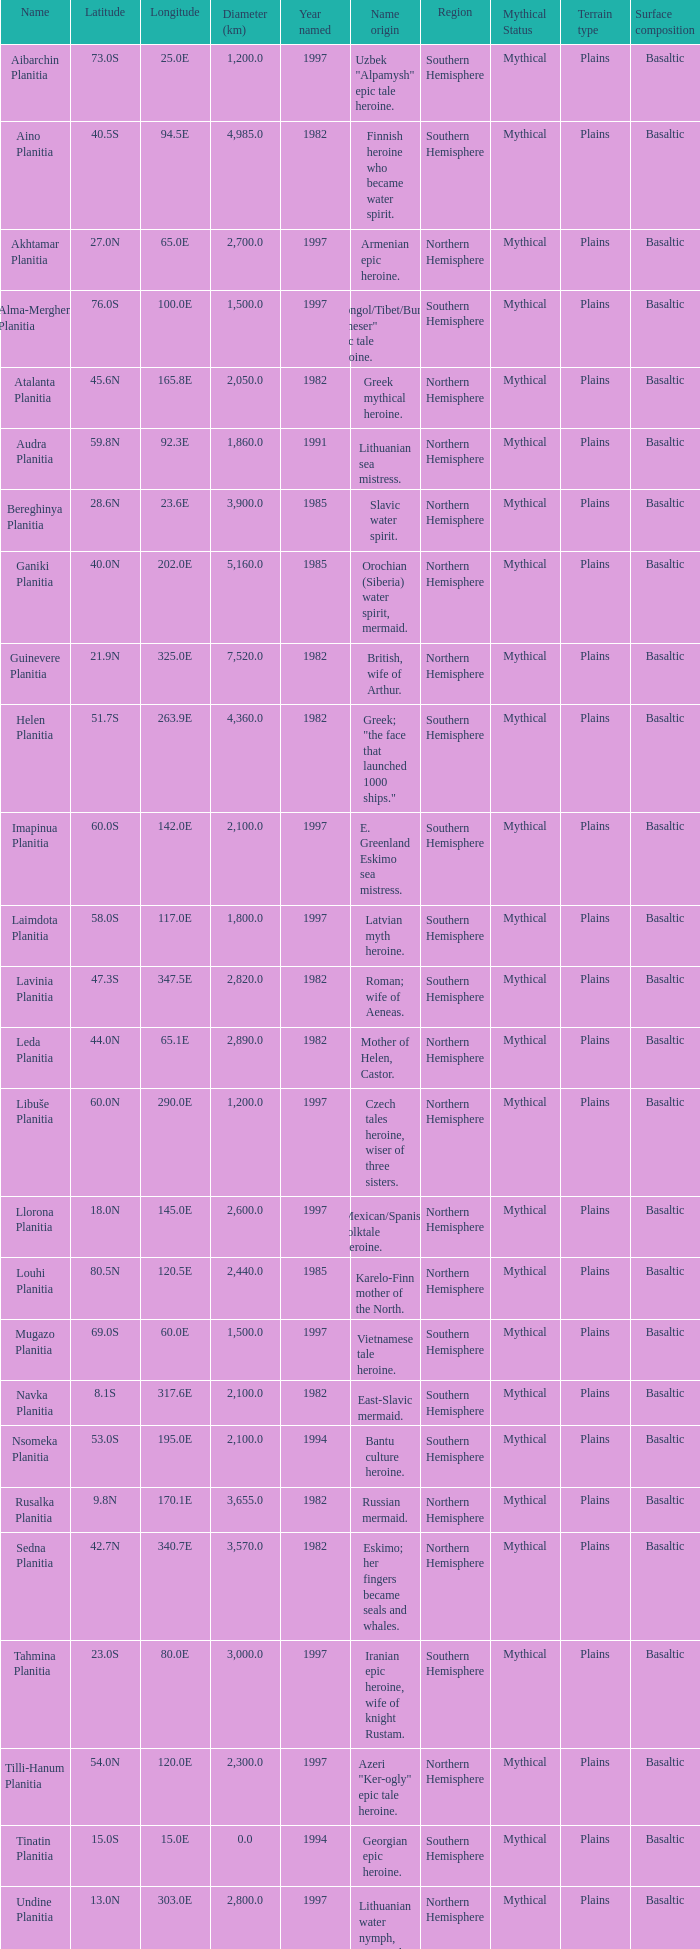What is the latitude of the feature of longitude 80.0e 23.0S. 